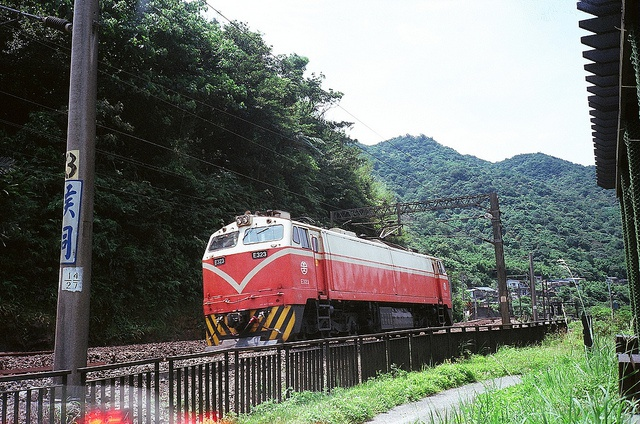Describe the objects in this image and their specific colors. I can see a train in black, lightgray, salmon, and brown tones in this image. 